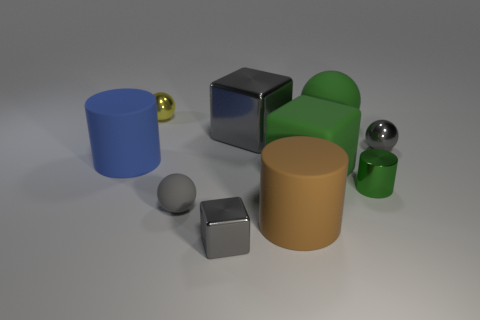How many other objects are the same color as the small metal cube?
Offer a terse response. 3. There is a gray block in front of the cylinder that is on the left side of the yellow metal object; what size is it?
Give a very brief answer. Small. Do the big cylinder on the left side of the big gray thing and the green block have the same material?
Your answer should be very brief. Yes. The tiny gray metal thing that is on the right side of the metal cylinder has what shape?
Ensure brevity in your answer.  Sphere. How many shiny cylinders have the same size as the blue thing?
Give a very brief answer. 0. How big is the yellow object?
Offer a very short reply. Small. How many objects are behind the blue thing?
Offer a terse response. 4. There is a yellow object that is the same material as the large gray object; what shape is it?
Provide a succinct answer. Sphere. Is the number of blue cylinders to the right of the big blue object less than the number of blue objects that are in front of the small gray metallic sphere?
Your response must be concise. Yes. Is the number of yellow spheres greater than the number of big things?
Provide a short and direct response. No. 